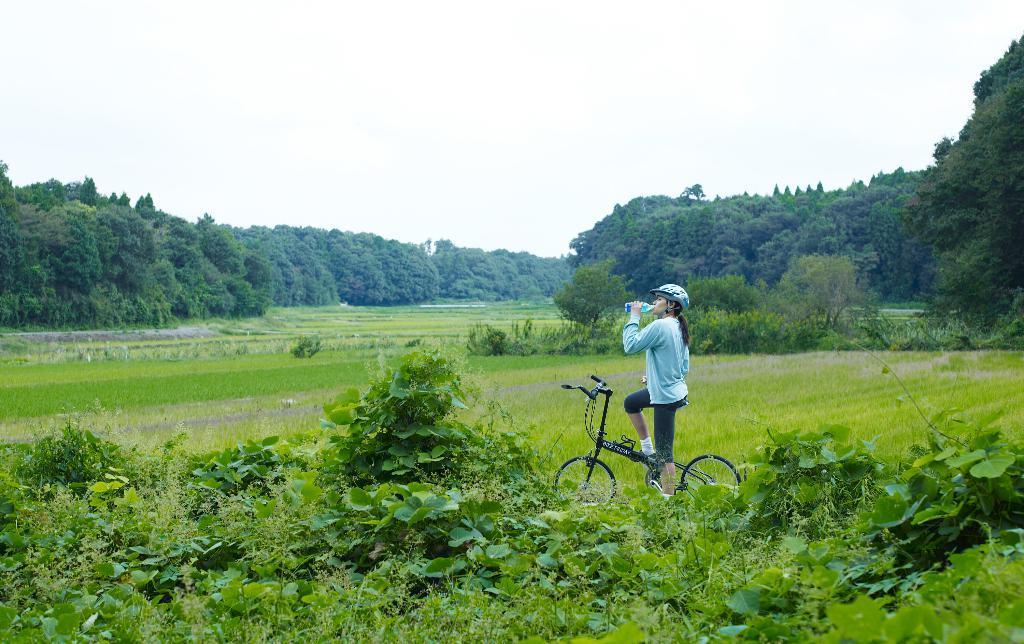How would you summarize this image in a sentence or two? In this picture I can see a woman holding a water bottle and sitting on the bicycle, there are plants, grass, there are trees, and in the background there is the sky. 